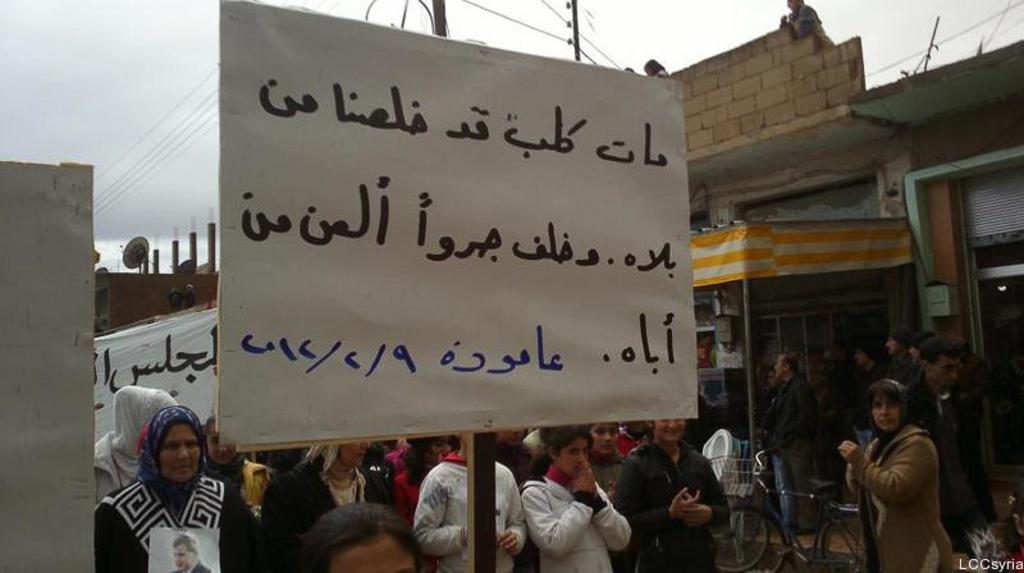Could you give a brief overview of what you see in this image? This is the picture of a place where we have some people and a board on which there are some things written and around there are some houses and buildings. 